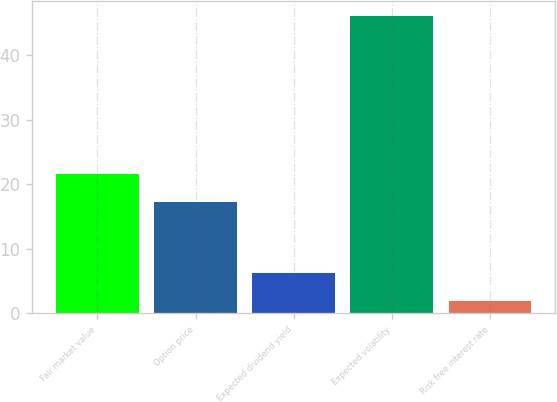Convert chart to OTSL. <chart><loc_0><loc_0><loc_500><loc_500><bar_chart><fcel>Fair market value<fcel>Option price<fcel>Expected dividend yield<fcel>Expected volatility<fcel>Risk free interest rate<nl><fcel>21.63<fcel>17.22<fcel>6.28<fcel>46<fcel>1.87<nl></chart> 